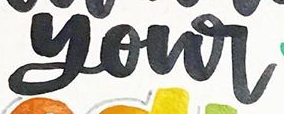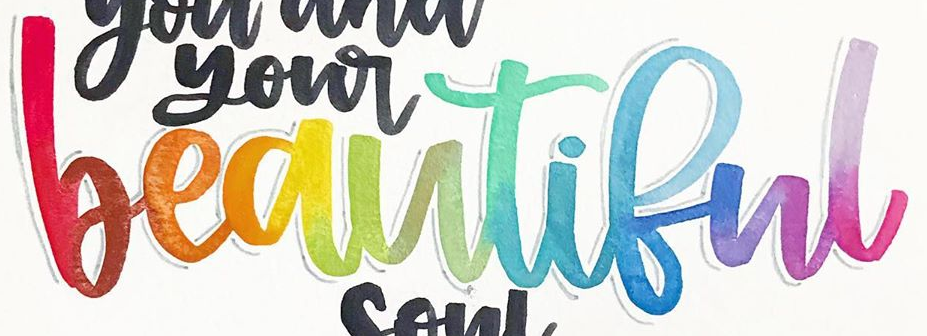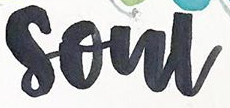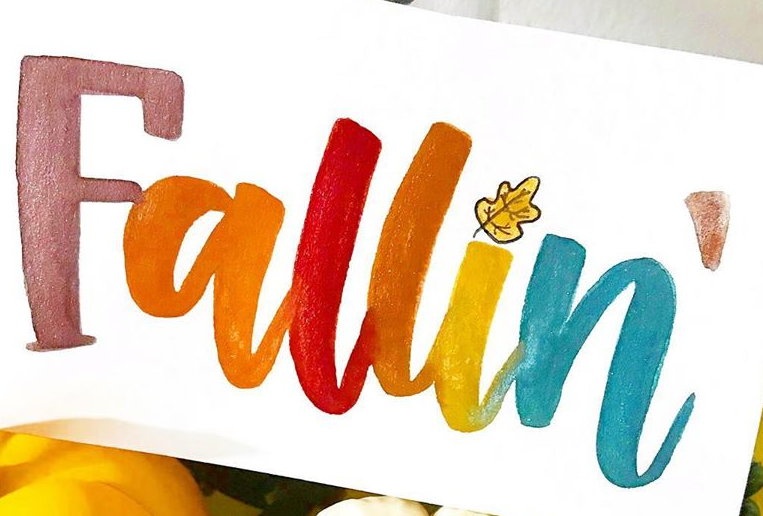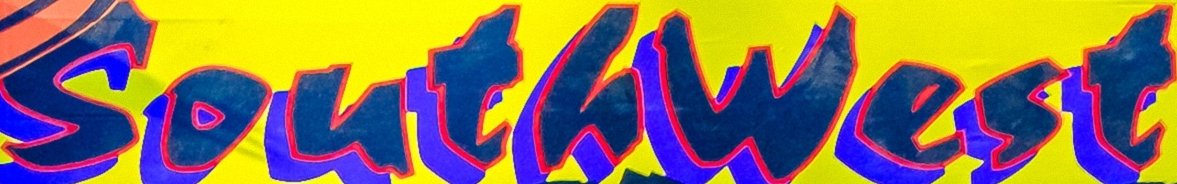Read the text from these images in sequence, separated by a semicolon. your; beautiful; soul; Fallin; Southwest 